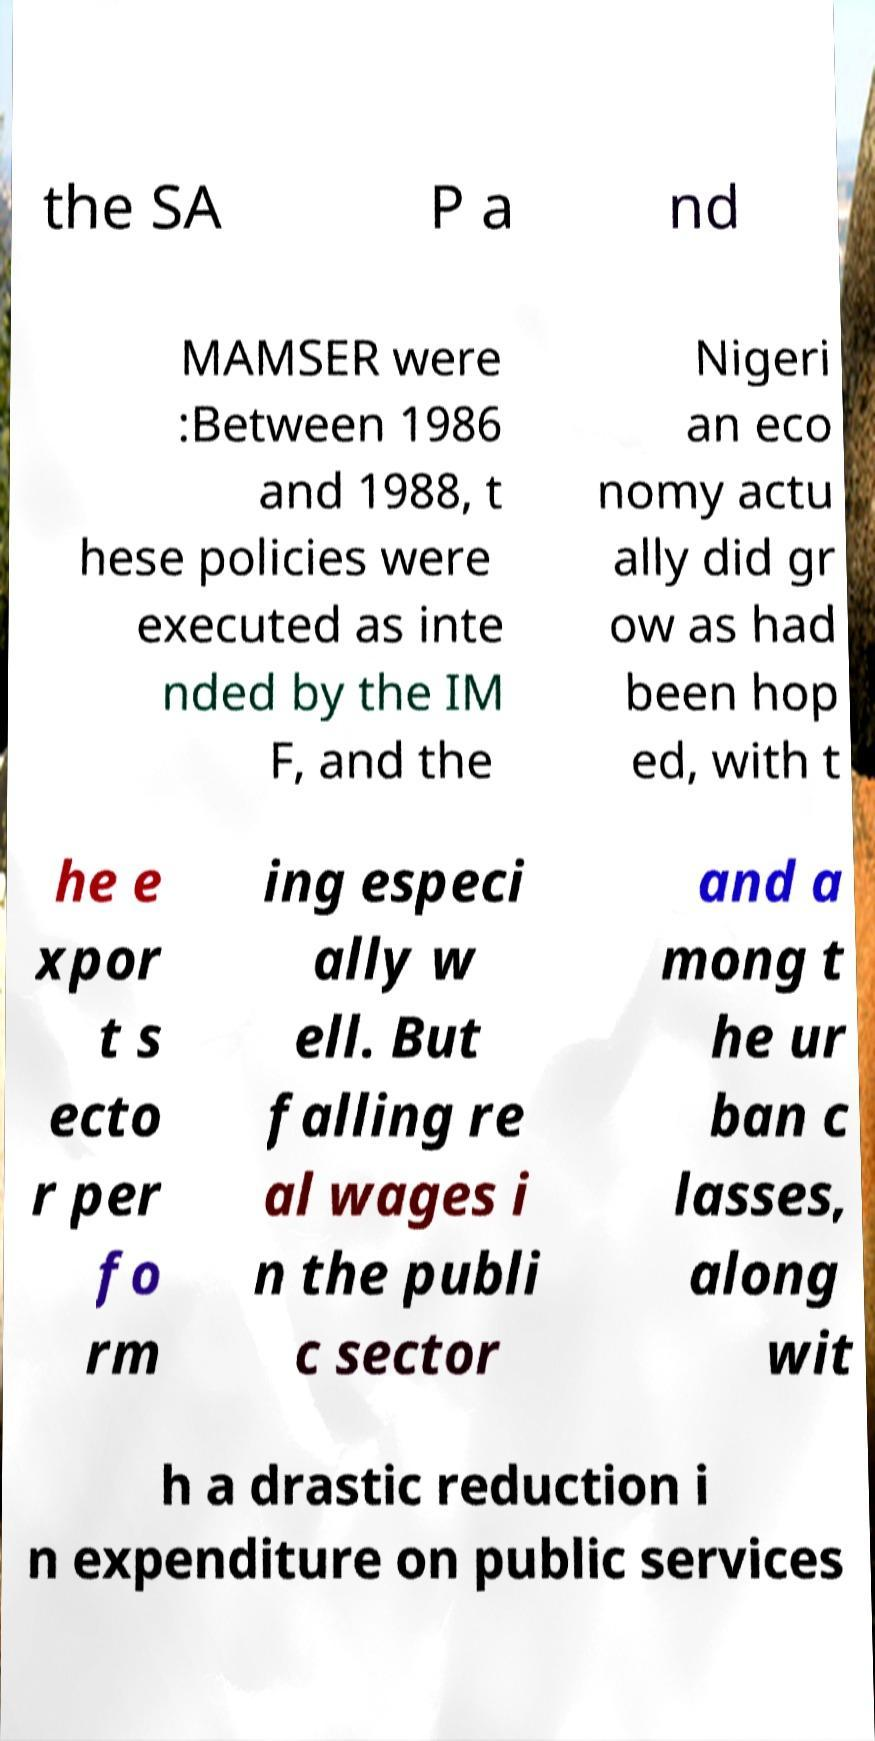Please read and relay the text visible in this image. What does it say? the SA P a nd MAMSER were :Between 1986 and 1988, t hese policies were executed as inte nded by the IM F, and the Nigeri an eco nomy actu ally did gr ow as had been hop ed, with t he e xpor t s ecto r per fo rm ing especi ally w ell. But falling re al wages i n the publi c sector and a mong t he ur ban c lasses, along wit h a drastic reduction i n expenditure on public services 